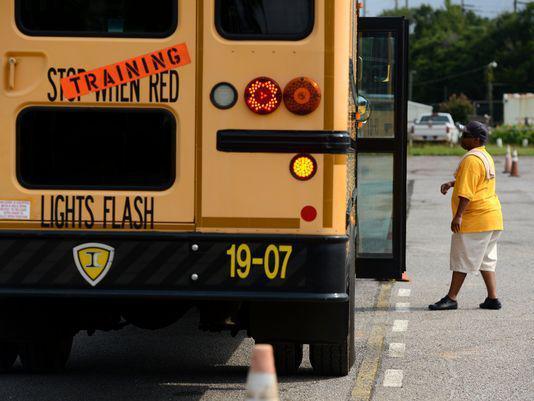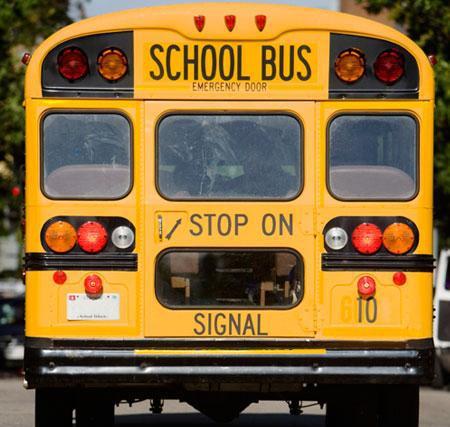The first image is the image on the left, the second image is the image on the right. Evaluate the accuracy of this statement regarding the images: "One image shows the rear of a bright yellow school bus, including its emergency door and sets of red and amber lights on the top.". Is it true? Answer yes or no. Yes. The first image is the image on the left, the second image is the image on the right. For the images shown, is this caption "One image in the pair shows a single school bus while the other shows at least three." true? Answer yes or no. No. 